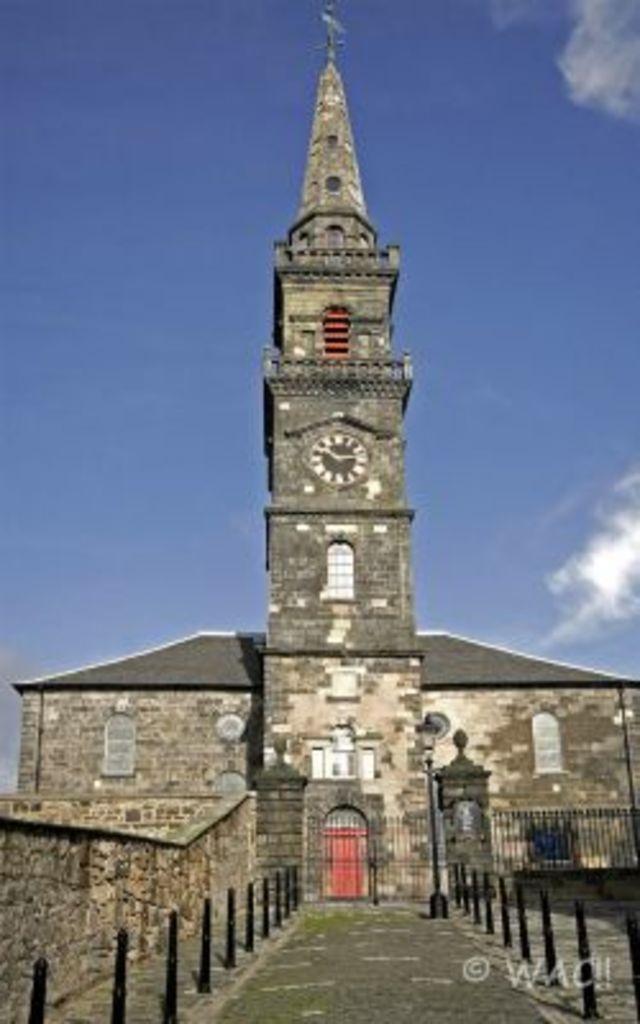Describe this image in one or two sentences. In the image there is a building in the front with a tower in the middle of it with a road in front of the building and above its sky with clouds. 